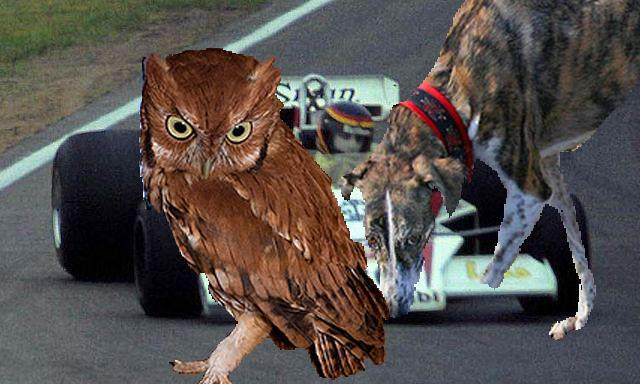How many unicorns are there in the image? There are no unicorns visible in the image; instead, the image features a fascinating combination of an owl and a cat superimposed with a racing car as a backdrop, creating a whimsical and surreal scene. 